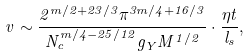Convert formula to latex. <formula><loc_0><loc_0><loc_500><loc_500>v \sim \frac { 2 ^ { m / 2 + 2 3 / 3 } \pi ^ { 3 m / 4 + 1 6 / 3 } } { N _ { c } ^ { m / 4 - 2 5 / 1 2 } g _ { Y } M ^ { 1 / 2 } } \cdot \frac { \eta t } { l _ { s } } ,</formula> 